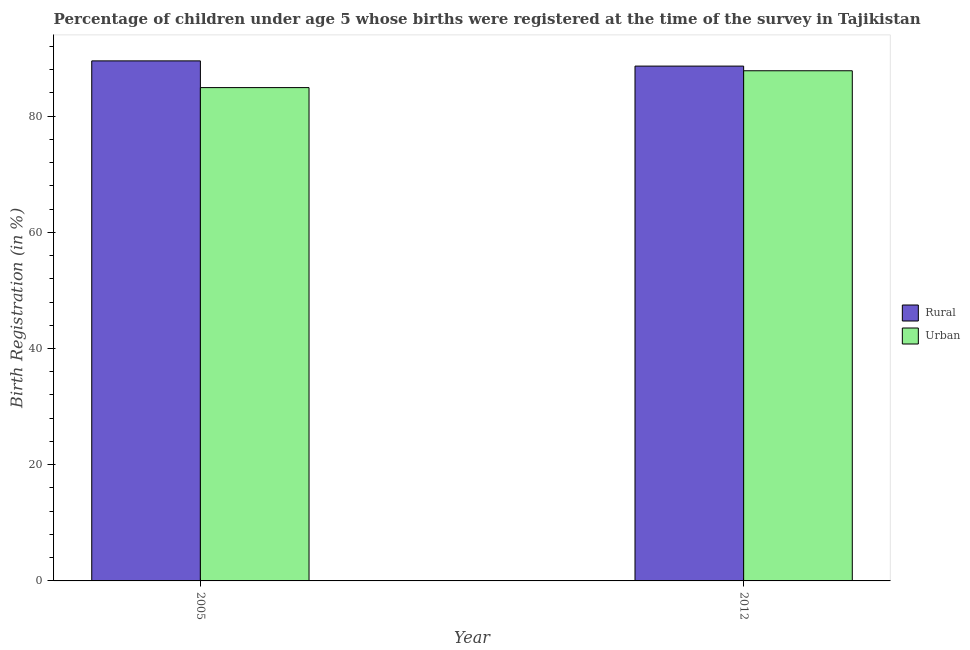How many groups of bars are there?
Your response must be concise. 2. Are the number of bars on each tick of the X-axis equal?
Make the answer very short. Yes. In how many cases, is the number of bars for a given year not equal to the number of legend labels?
Your answer should be very brief. 0. What is the urban birth registration in 2005?
Make the answer very short. 84.9. Across all years, what is the maximum rural birth registration?
Offer a terse response. 89.5. Across all years, what is the minimum rural birth registration?
Offer a very short reply. 88.6. In which year was the rural birth registration maximum?
Ensure brevity in your answer.  2005. In which year was the rural birth registration minimum?
Offer a very short reply. 2012. What is the total rural birth registration in the graph?
Offer a very short reply. 178.1. What is the difference between the rural birth registration in 2005 and that in 2012?
Make the answer very short. 0.9. What is the difference between the urban birth registration in 2012 and the rural birth registration in 2005?
Ensure brevity in your answer.  2.9. What is the average urban birth registration per year?
Provide a short and direct response. 86.35. In the year 2012, what is the difference between the rural birth registration and urban birth registration?
Your answer should be compact. 0. In how many years, is the rural birth registration greater than 56 %?
Provide a short and direct response. 2. What is the ratio of the rural birth registration in 2005 to that in 2012?
Offer a very short reply. 1.01. Is the rural birth registration in 2005 less than that in 2012?
Offer a terse response. No. What does the 2nd bar from the left in 2005 represents?
Your answer should be compact. Urban. What does the 1st bar from the right in 2012 represents?
Ensure brevity in your answer.  Urban. How many bars are there?
Ensure brevity in your answer.  4. Are all the bars in the graph horizontal?
Your response must be concise. No. How many years are there in the graph?
Make the answer very short. 2. Are the values on the major ticks of Y-axis written in scientific E-notation?
Your response must be concise. No. Does the graph contain any zero values?
Ensure brevity in your answer.  No. What is the title of the graph?
Provide a succinct answer. Percentage of children under age 5 whose births were registered at the time of the survey in Tajikistan. What is the label or title of the X-axis?
Provide a short and direct response. Year. What is the label or title of the Y-axis?
Your answer should be very brief. Birth Registration (in %). What is the Birth Registration (in %) in Rural in 2005?
Ensure brevity in your answer.  89.5. What is the Birth Registration (in %) in Urban in 2005?
Your answer should be compact. 84.9. What is the Birth Registration (in %) of Rural in 2012?
Your answer should be compact. 88.6. What is the Birth Registration (in %) of Urban in 2012?
Ensure brevity in your answer.  87.8. Across all years, what is the maximum Birth Registration (in %) in Rural?
Offer a very short reply. 89.5. Across all years, what is the maximum Birth Registration (in %) of Urban?
Give a very brief answer. 87.8. Across all years, what is the minimum Birth Registration (in %) in Rural?
Give a very brief answer. 88.6. Across all years, what is the minimum Birth Registration (in %) of Urban?
Keep it short and to the point. 84.9. What is the total Birth Registration (in %) in Rural in the graph?
Ensure brevity in your answer.  178.1. What is the total Birth Registration (in %) of Urban in the graph?
Provide a succinct answer. 172.7. What is the difference between the Birth Registration (in %) in Rural in 2005 and the Birth Registration (in %) in Urban in 2012?
Provide a short and direct response. 1.7. What is the average Birth Registration (in %) of Rural per year?
Offer a terse response. 89.05. What is the average Birth Registration (in %) in Urban per year?
Keep it short and to the point. 86.35. In the year 2005, what is the difference between the Birth Registration (in %) in Rural and Birth Registration (in %) in Urban?
Keep it short and to the point. 4.6. In the year 2012, what is the difference between the Birth Registration (in %) in Rural and Birth Registration (in %) in Urban?
Offer a terse response. 0.8. What is the ratio of the Birth Registration (in %) of Rural in 2005 to that in 2012?
Offer a very short reply. 1.01. What is the difference between the highest and the second highest Birth Registration (in %) of Rural?
Your answer should be very brief. 0.9. What is the difference between the highest and the second highest Birth Registration (in %) of Urban?
Ensure brevity in your answer.  2.9. What is the difference between the highest and the lowest Birth Registration (in %) of Rural?
Keep it short and to the point. 0.9. 